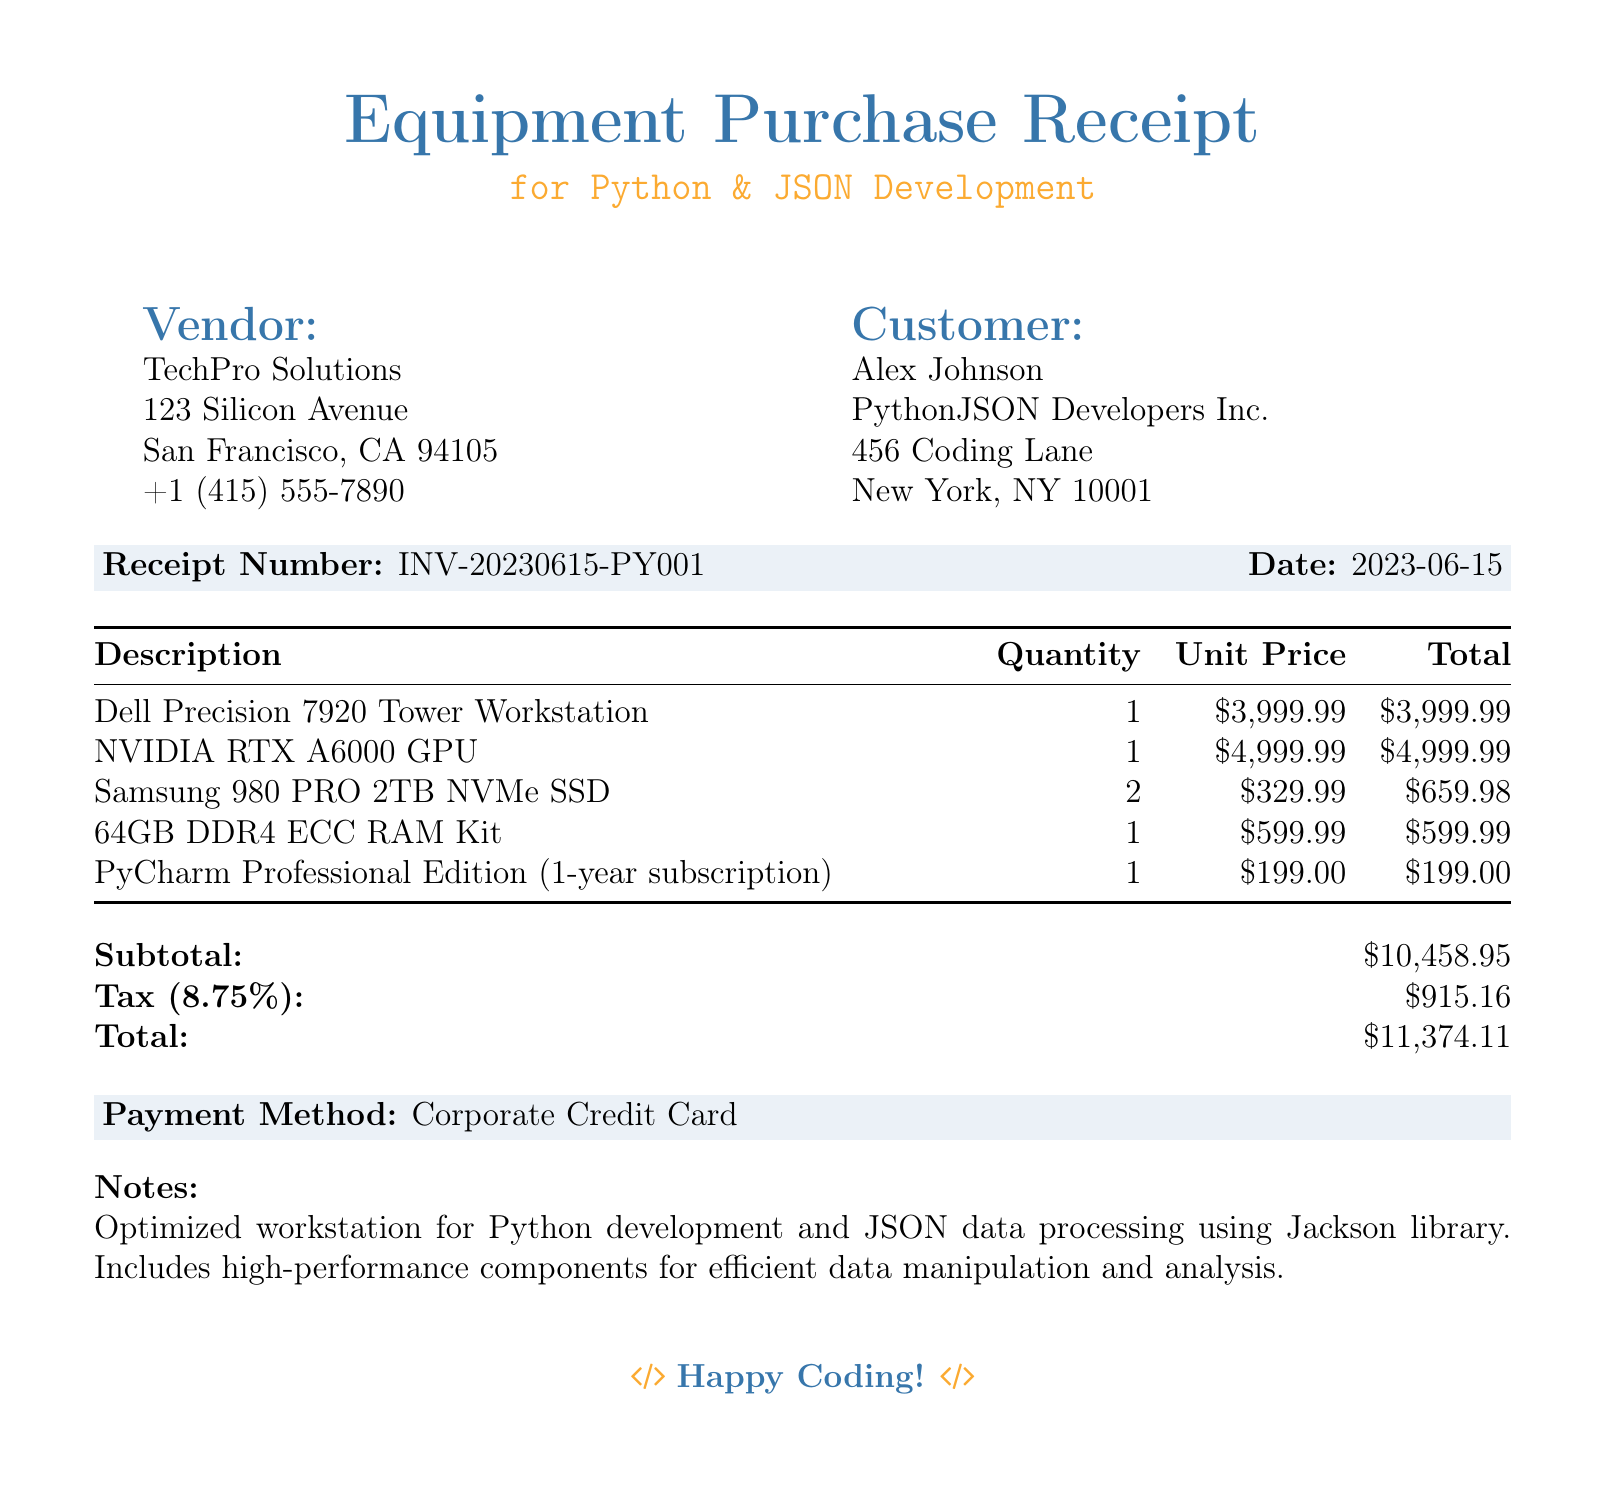What is the vendor's name? The vendor's name is listed at the top of the document under "Vendor," which is TechPro Solutions.
Answer: TechPro Solutions What is the total amount of tax? The tax amount is shown in the second tabular section of the document as 8.75 percent of the subtotal, which is 915.16.
Answer: $915.16 What is the receipt number? The receipt number is provided in the shaded box in the document, which reads INV-20230615-PY001.
Answer: INV-20230615-PY001 How many units of the Samsung 980 PRO 2TB NVMe SSD were purchased? The quantity of Samsung 980 PRO 2TB NVMe SSD is listed as 2 in the itemized section of the document.
Answer: 2 What is the unit price of the NVIDIA RTX A6000 GPU? The document lists the unit price of the NVIDIA RTX A6000 GPU next to its description, which is 4999.99.
Answer: $4,999.99 What is the date of the purchase? The date of the receipt is located in the same shaded box as the receipt number, which is shown as 2023-06-15.
Answer: 2023-06-15 How much is the subtotal before tax? The subtotal is clearly indicated in the second tabular section of the document exactly as 10458.95.
Answer: $10,458.95 What payment method was used? The payment method is stated in another shaded box in the document as Corporate Credit Card.
Answer: Corporate Credit Card 